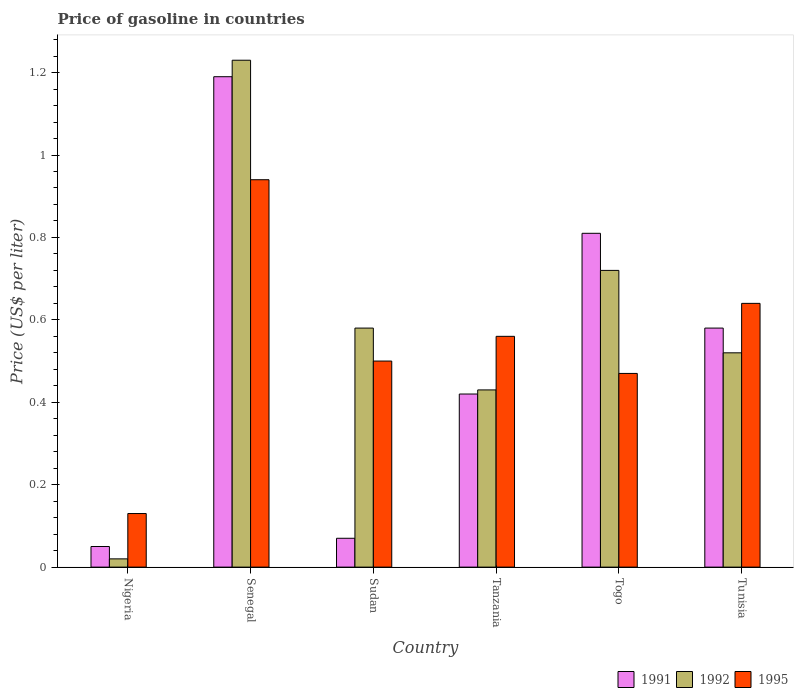How many different coloured bars are there?
Offer a terse response. 3. Are the number of bars per tick equal to the number of legend labels?
Ensure brevity in your answer.  Yes. Are the number of bars on each tick of the X-axis equal?
Keep it short and to the point. Yes. How many bars are there on the 5th tick from the left?
Your response must be concise. 3. What is the label of the 2nd group of bars from the left?
Your answer should be very brief. Senegal. In how many cases, is the number of bars for a given country not equal to the number of legend labels?
Make the answer very short. 0. What is the price of gasoline in 1995 in Tunisia?
Provide a succinct answer. 0.64. In which country was the price of gasoline in 1992 maximum?
Offer a very short reply. Senegal. In which country was the price of gasoline in 1992 minimum?
Provide a succinct answer. Nigeria. What is the total price of gasoline in 1992 in the graph?
Give a very brief answer. 3.5. What is the difference between the price of gasoline in 1992 in Nigeria and that in Tanzania?
Ensure brevity in your answer.  -0.41. What is the difference between the price of gasoline in 1992 in Togo and the price of gasoline in 1991 in Sudan?
Offer a very short reply. 0.65. What is the average price of gasoline in 1992 per country?
Ensure brevity in your answer.  0.58. What is the difference between the price of gasoline of/in 1991 and price of gasoline of/in 1992 in Tanzania?
Your answer should be compact. -0.01. What is the ratio of the price of gasoline in 1995 in Tanzania to that in Tunisia?
Offer a terse response. 0.88. What is the difference between the highest and the second highest price of gasoline in 1995?
Your answer should be very brief. 0.3. What is the difference between the highest and the lowest price of gasoline in 1995?
Make the answer very short. 0.81. In how many countries, is the price of gasoline in 1995 greater than the average price of gasoline in 1995 taken over all countries?
Make the answer very short. 3. Is it the case that in every country, the sum of the price of gasoline in 1992 and price of gasoline in 1991 is greater than the price of gasoline in 1995?
Make the answer very short. No. How many bars are there?
Offer a very short reply. 18. Are all the bars in the graph horizontal?
Your response must be concise. No. What is the difference between two consecutive major ticks on the Y-axis?
Offer a very short reply. 0.2. Where does the legend appear in the graph?
Offer a terse response. Bottom right. What is the title of the graph?
Your response must be concise. Price of gasoline in countries. What is the label or title of the Y-axis?
Give a very brief answer. Price (US$ per liter). What is the Price (US$ per liter) of 1992 in Nigeria?
Make the answer very short. 0.02. What is the Price (US$ per liter) in 1995 in Nigeria?
Make the answer very short. 0.13. What is the Price (US$ per liter) in 1991 in Senegal?
Provide a short and direct response. 1.19. What is the Price (US$ per liter) in 1992 in Senegal?
Provide a short and direct response. 1.23. What is the Price (US$ per liter) of 1991 in Sudan?
Make the answer very short. 0.07. What is the Price (US$ per liter) in 1992 in Sudan?
Make the answer very short. 0.58. What is the Price (US$ per liter) of 1995 in Sudan?
Offer a very short reply. 0.5. What is the Price (US$ per liter) of 1991 in Tanzania?
Your answer should be very brief. 0.42. What is the Price (US$ per liter) of 1992 in Tanzania?
Provide a succinct answer. 0.43. What is the Price (US$ per liter) of 1995 in Tanzania?
Your response must be concise. 0.56. What is the Price (US$ per liter) of 1991 in Togo?
Offer a very short reply. 0.81. What is the Price (US$ per liter) in 1992 in Togo?
Ensure brevity in your answer.  0.72. What is the Price (US$ per liter) of 1995 in Togo?
Give a very brief answer. 0.47. What is the Price (US$ per liter) in 1991 in Tunisia?
Keep it short and to the point. 0.58. What is the Price (US$ per liter) in 1992 in Tunisia?
Offer a terse response. 0.52. What is the Price (US$ per liter) in 1995 in Tunisia?
Offer a very short reply. 0.64. Across all countries, what is the maximum Price (US$ per liter) in 1991?
Your answer should be very brief. 1.19. Across all countries, what is the maximum Price (US$ per liter) in 1992?
Offer a very short reply. 1.23. Across all countries, what is the maximum Price (US$ per liter) of 1995?
Your response must be concise. 0.94. Across all countries, what is the minimum Price (US$ per liter) in 1992?
Offer a terse response. 0.02. Across all countries, what is the minimum Price (US$ per liter) of 1995?
Your answer should be compact. 0.13. What is the total Price (US$ per liter) in 1991 in the graph?
Provide a short and direct response. 3.12. What is the total Price (US$ per liter) in 1995 in the graph?
Make the answer very short. 3.24. What is the difference between the Price (US$ per liter) of 1991 in Nigeria and that in Senegal?
Your response must be concise. -1.14. What is the difference between the Price (US$ per liter) of 1992 in Nigeria and that in Senegal?
Your answer should be very brief. -1.21. What is the difference between the Price (US$ per liter) in 1995 in Nigeria and that in Senegal?
Make the answer very short. -0.81. What is the difference between the Price (US$ per liter) of 1991 in Nigeria and that in Sudan?
Offer a very short reply. -0.02. What is the difference between the Price (US$ per liter) of 1992 in Nigeria and that in Sudan?
Your answer should be very brief. -0.56. What is the difference between the Price (US$ per liter) in 1995 in Nigeria and that in Sudan?
Ensure brevity in your answer.  -0.37. What is the difference between the Price (US$ per liter) in 1991 in Nigeria and that in Tanzania?
Your answer should be very brief. -0.37. What is the difference between the Price (US$ per liter) in 1992 in Nigeria and that in Tanzania?
Offer a terse response. -0.41. What is the difference between the Price (US$ per liter) in 1995 in Nigeria and that in Tanzania?
Keep it short and to the point. -0.43. What is the difference between the Price (US$ per liter) of 1991 in Nigeria and that in Togo?
Offer a terse response. -0.76. What is the difference between the Price (US$ per liter) in 1995 in Nigeria and that in Togo?
Give a very brief answer. -0.34. What is the difference between the Price (US$ per liter) in 1991 in Nigeria and that in Tunisia?
Give a very brief answer. -0.53. What is the difference between the Price (US$ per liter) in 1992 in Nigeria and that in Tunisia?
Keep it short and to the point. -0.5. What is the difference between the Price (US$ per liter) of 1995 in Nigeria and that in Tunisia?
Your response must be concise. -0.51. What is the difference between the Price (US$ per liter) in 1991 in Senegal and that in Sudan?
Ensure brevity in your answer.  1.12. What is the difference between the Price (US$ per liter) in 1992 in Senegal and that in Sudan?
Give a very brief answer. 0.65. What is the difference between the Price (US$ per liter) in 1995 in Senegal and that in Sudan?
Give a very brief answer. 0.44. What is the difference between the Price (US$ per liter) of 1991 in Senegal and that in Tanzania?
Provide a short and direct response. 0.77. What is the difference between the Price (US$ per liter) in 1995 in Senegal and that in Tanzania?
Your answer should be very brief. 0.38. What is the difference between the Price (US$ per liter) in 1991 in Senegal and that in Togo?
Your answer should be compact. 0.38. What is the difference between the Price (US$ per liter) in 1992 in Senegal and that in Togo?
Make the answer very short. 0.51. What is the difference between the Price (US$ per liter) in 1995 in Senegal and that in Togo?
Offer a terse response. 0.47. What is the difference between the Price (US$ per liter) of 1991 in Senegal and that in Tunisia?
Offer a terse response. 0.61. What is the difference between the Price (US$ per liter) of 1992 in Senegal and that in Tunisia?
Offer a very short reply. 0.71. What is the difference between the Price (US$ per liter) in 1991 in Sudan and that in Tanzania?
Your answer should be very brief. -0.35. What is the difference between the Price (US$ per liter) of 1992 in Sudan and that in Tanzania?
Offer a terse response. 0.15. What is the difference between the Price (US$ per liter) in 1995 in Sudan and that in Tanzania?
Your response must be concise. -0.06. What is the difference between the Price (US$ per liter) of 1991 in Sudan and that in Togo?
Ensure brevity in your answer.  -0.74. What is the difference between the Price (US$ per liter) in 1992 in Sudan and that in Togo?
Make the answer very short. -0.14. What is the difference between the Price (US$ per liter) of 1991 in Sudan and that in Tunisia?
Provide a short and direct response. -0.51. What is the difference between the Price (US$ per liter) of 1992 in Sudan and that in Tunisia?
Provide a succinct answer. 0.06. What is the difference between the Price (US$ per liter) in 1995 in Sudan and that in Tunisia?
Offer a very short reply. -0.14. What is the difference between the Price (US$ per liter) in 1991 in Tanzania and that in Togo?
Your answer should be very brief. -0.39. What is the difference between the Price (US$ per liter) of 1992 in Tanzania and that in Togo?
Give a very brief answer. -0.29. What is the difference between the Price (US$ per liter) of 1995 in Tanzania and that in Togo?
Your response must be concise. 0.09. What is the difference between the Price (US$ per liter) of 1991 in Tanzania and that in Tunisia?
Provide a short and direct response. -0.16. What is the difference between the Price (US$ per liter) in 1992 in Tanzania and that in Tunisia?
Your response must be concise. -0.09. What is the difference between the Price (US$ per liter) of 1995 in Tanzania and that in Tunisia?
Keep it short and to the point. -0.08. What is the difference between the Price (US$ per liter) of 1991 in Togo and that in Tunisia?
Make the answer very short. 0.23. What is the difference between the Price (US$ per liter) of 1992 in Togo and that in Tunisia?
Keep it short and to the point. 0.2. What is the difference between the Price (US$ per liter) in 1995 in Togo and that in Tunisia?
Provide a succinct answer. -0.17. What is the difference between the Price (US$ per liter) in 1991 in Nigeria and the Price (US$ per liter) in 1992 in Senegal?
Ensure brevity in your answer.  -1.18. What is the difference between the Price (US$ per liter) of 1991 in Nigeria and the Price (US$ per liter) of 1995 in Senegal?
Your answer should be compact. -0.89. What is the difference between the Price (US$ per liter) in 1992 in Nigeria and the Price (US$ per liter) in 1995 in Senegal?
Make the answer very short. -0.92. What is the difference between the Price (US$ per liter) in 1991 in Nigeria and the Price (US$ per liter) in 1992 in Sudan?
Offer a very short reply. -0.53. What is the difference between the Price (US$ per liter) of 1991 in Nigeria and the Price (US$ per liter) of 1995 in Sudan?
Provide a succinct answer. -0.45. What is the difference between the Price (US$ per liter) in 1992 in Nigeria and the Price (US$ per liter) in 1995 in Sudan?
Your answer should be compact. -0.48. What is the difference between the Price (US$ per liter) in 1991 in Nigeria and the Price (US$ per liter) in 1992 in Tanzania?
Your answer should be very brief. -0.38. What is the difference between the Price (US$ per liter) of 1991 in Nigeria and the Price (US$ per liter) of 1995 in Tanzania?
Your answer should be compact. -0.51. What is the difference between the Price (US$ per liter) of 1992 in Nigeria and the Price (US$ per liter) of 1995 in Tanzania?
Offer a terse response. -0.54. What is the difference between the Price (US$ per liter) in 1991 in Nigeria and the Price (US$ per liter) in 1992 in Togo?
Offer a very short reply. -0.67. What is the difference between the Price (US$ per liter) in 1991 in Nigeria and the Price (US$ per liter) in 1995 in Togo?
Your response must be concise. -0.42. What is the difference between the Price (US$ per liter) of 1992 in Nigeria and the Price (US$ per liter) of 1995 in Togo?
Keep it short and to the point. -0.45. What is the difference between the Price (US$ per liter) in 1991 in Nigeria and the Price (US$ per liter) in 1992 in Tunisia?
Provide a succinct answer. -0.47. What is the difference between the Price (US$ per liter) of 1991 in Nigeria and the Price (US$ per liter) of 1995 in Tunisia?
Offer a very short reply. -0.59. What is the difference between the Price (US$ per liter) of 1992 in Nigeria and the Price (US$ per liter) of 1995 in Tunisia?
Make the answer very short. -0.62. What is the difference between the Price (US$ per liter) in 1991 in Senegal and the Price (US$ per liter) in 1992 in Sudan?
Ensure brevity in your answer.  0.61. What is the difference between the Price (US$ per liter) in 1991 in Senegal and the Price (US$ per liter) in 1995 in Sudan?
Ensure brevity in your answer.  0.69. What is the difference between the Price (US$ per liter) in 1992 in Senegal and the Price (US$ per liter) in 1995 in Sudan?
Make the answer very short. 0.73. What is the difference between the Price (US$ per liter) of 1991 in Senegal and the Price (US$ per liter) of 1992 in Tanzania?
Give a very brief answer. 0.76. What is the difference between the Price (US$ per liter) of 1991 in Senegal and the Price (US$ per liter) of 1995 in Tanzania?
Provide a succinct answer. 0.63. What is the difference between the Price (US$ per liter) of 1992 in Senegal and the Price (US$ per liter) of 1995 in Tanzania?
Keep it short and to the point. 0.67. What is the difference between the Price (US$ per liter) of 1991 in Senegal and the Price (US$ per liter) of 1992 in Togo?
Make the answer very short. 0.47. What is the difference between the Price (US$ per liter) in 1991 in Senegal and the Price (US$ per liter) in 1995 in Togo?
Ensure brevity in your answer.  0.72. What is the difference between the Price (US$ per liter) of 1992 in Senegal and the Price (US$ per liter) of 1995 in Togo?
Your answer should be very brief. 0.76. What is the difference between the Price (US$ per liter) in 1991 in Senegal and the Price (US$ per liter) in 1992 in Tunisia?
Ensure brevity in your answer.  0.67. What is the difference between the Price (US$ per liter) in 1991 in Senegal and the Price (US$ per liter) in 1995 in Tunisia?
Ensure brevity in your answer.  0.55. What is the difference between the Price (US$ per liter) of 1992 in Senegal and the Price (US$ per liter) of 1995 in Tunisia?
Your response must be concise. 0.59. What is the difference between the Price (US$ per liter) in 1991 in Sudan and the Price (US$ per liter) in 1992 in Tanzania?
Make the answer very short. -0.36. What is the difference between the Price (US$ per liter) in 1991 in Sudan and the Price (US$ per liter) in 1995 in Tanzania?
Provide a succinct answer. -0.49. What is the difference between the Price (US$ per liter) of 1991 in Sudan and the Price (US$ per liter) of 1992 in Togo?
Give a very brief answer. -0.65. What is the difference between the Price (US$ per liter) of 1992 in Sudan and the Price (US$ per liter) of 1995 in Togo?
Offer a terse response. 0.11. What is the difference between the Price (US$ per liter) in 1991 in Sudan and the Price (US$ per liter) in 1992 in Tunisia?
Your response must be concise. -0.45. What is the difference between the Price (US$ per liter) of 1991 in Sudan and the Price (US$ per liter) of 1995 in Tunisia?
Make the answer very short. -0.57. What is the difference between the Price (US$ per liter) in 1992 in Sudan and the Price (US$ per liter) in 1995 in Tunisia?
Provide a succinct answer. -0.06. What is the difference between the Price (US$ per liter) of 1991 in Tanzania and the Price (US$ per liter) of 1995 in Togo?
Your response must be concise. -0.05. What is the difference between the Price (US$ per liter) of 1992 in Tanzania and the Price (US$ per liter) of 1995 in Togo?
Offer a very short reply. -0.04. What is the difference between the Price (US$ per liter) in 1991 in Tanzania and the Price (US$ per liter) in 1995 in Tunisia?
Provide a succinct answer. -0.22. What is the difference between the Price (US$ per liter) of 1992 in Tanzania and the Price (US$ per liter) of 1995 in Tunisia?
Provide a short and direct response. -0.21. What is the difference between the Price (US$ per liter) in 1991 in Togo and the Price (US$ per liter) in 1992 in Tunisia?
Your answer should be very brief. 0.29. What is the difference between the Price (US$ per liter) in 1991 in Togo and the Price (US$ per liter) in 1995 in Tunisia?
Your answer should be very brief. 0.17. What is the difference between the Price (US$ per liter) of 1992 in Togo and the Price (US$ per liter) of 1995 in Tunisia?
Offer a terse response. 0.08. What is the average Price (US$ per liter) in 1991 per country?
Keep it short and to the point. 0.52. What is the average Price (US$ per liter) of 1992 per country?
Provide a succinct answer. 0.58. What is the average Price (US$ per liter) of 1995 per country?
Make the answer very short. 0.54. What is the difference between the Price (US$ per liter) in 1991 and Price (US$ per liter) in 1995 in Nigeria?
Provide a short and direct response. -0.08. What is the difference between the Price (US$ per liter) in 1992 and Price (US$ per liter) in 1995 in Nigeria?
Provide a short and direct response. -0.11. What is the difference between the Price (US$ per liter) of 1991 and Price (US$ per liter) of 1992 in Senegal?
Ensure brevity in your answer.  -0.04. What is the difference between the Price (US$ per liter) of 1992 and Price (US$ per liter) of 1995 in Senegal?
Your answer should be very brief. 0.29. What is the difference between the Price (US$ per liter) in 1991 and Price (US$ per liter) in 1992 in Sudan?
Provide a succinct answer. -0.51. What is the difference between the Price (US$ per liter) of 1991 and Price (US$ per liter) of 1995 in Sudan?
Ensure brevity in your answer.  -0.43. What is the difference between the Price (US$ per liter) of 1992 and Price (US$ per liter) of 1995 in Sudan?
Make the answer very short. 0.08. What is the difference between the Price (US$ per liter) in 1991 and Price (US$ per liter) in 1992 in Tanzania?
Your response must be concise. -0.01. What is the difference between the Price (US$ per liter) in 1991 and Price (US$ per liter) in 1995 in Tanzania?
Provide a succinct answer. -0.14. What is the difference between the Price (US$ per liter) in 1992 and Price (US$ per liter) in 1995 in Tanzania?
Ensure brevity in your answer.  -0.13. What is the difference between the Price (US$ per liter) of 1991 and Price (US$ per liter) of 1992 in Togo?
Your response must be concise. 0.09. What is the difference between the Price (US$ per liter) in 1991 and Price (US$ per liter) in 1995 in Togo?
Provide a short and direct response. 0.34. What is the difference between the Price (US$ per liter) in 1991 and Price (US$ per liter) in 1995 in Tunisia?
Your response must be concise. -0.06. What is the difference between the Price (US$ per liter) in 1992 and Price (US$ per liter) in 1995 in Tunisia?
Provide a short and direct response. -0.12. What is the ratio of the Price (US$ per liter) in 1991 in Nigeria to that in Senegal?
Provide a short and direct response. 0.04. What is the ratio of the Price (US$ per liter) in 1992 in Nigeria to that in Senegal?
Give a very brief answer. 0.02. What is the ratio of the Price (US$ per liter) in 1995 in Nigeria to that in Senegal?
Offer a very short reply. 0.14. What is the ratio of the Price (US$ per liter) of 1991 in Nigeria to that in Sudan?
Provide a succinct answer. 0.71. What is the ratio of the Price (US$ per liter) in 1992 in Nigeria to that in Sudan?
Ensure brevity in your answer.  0.03. What is the ratio of the Price (US$ per liter) in 1995 in Nigeria to that in Sudan?
Your response must be concise. 0.26. What is the ratio of the Price (US$ per liter) of 1991 in Nigeria to that in Tanzania?
Ensure brevity in your answer.  0.12. What is the ratio of the Price (US$ per liter) in 1992 in Nigeria to that in Tanzania?
Offer a very short reply. 0.05. What is the ratio of the Price (US$ per liter) in 1995 in Nigeria to that in Tanzania?
Offer a very short reply. 0.23. What is the ratio of the Price (US$ per liter) in 1991 in Nigeria to that in Togo?
Offer a very short reply. 0.06. What is the ratio of the Price (US$ per liter) of 1992 in Nigeria to that in Togo?
Ensure brevity in your answer.  0.03. What is the ratio of the Price (US$ per liter) of 1995 in Nigeria to that in Togo?
Provide a succinct answer. 0.28. What is the ratio of the Price (US$ per liter) in 1991 in Nigeria to that in Tunisia?
Ensure brevity in your answer.  0.09. What is the ratio of the Price (US$ per liter) in 1992 in Nigeria to that in Tunisia?
Provide a succinct answer. 0.04. What is the ratio of the Price (US$ per liter) of 1995 in Nigeria to that in Tunisia?
Provide a short and direct response. 0.2. What is the ratio of the Price (US$ per liter) in 1992 in Senegal to that in Sudan?
Offer a very short reply. 2.12. What is the ratio of the Price (US$ per liter) in 1995 in Senegal to that in Sudan?
Provide a succinct answer. 1.88. What is the ratio of the Price (US$ per liter) in 1991 in Senegal to that in Tanzania?
Make the answer very short. 2.83. What is the ratio of the Price (US$ per liter) of 1992 in Senegal to that in Tanzania?
Provide a succinct answer. 2.86. What is the ratio of the Price (US$ per liter) in 1995 in Senegal to that in Tanzania?
Provide a short and direct response. 1.68. What is the ratio of the Price (US$ per liter) in 1991 in Senegal to that in Togo?
Make the answer very short. 1.47. What is the ratio of the Price (US$ per liter) in 1992 in Senegal to that in Togo?
Your answer should be compact. 1.71. What is the ratio of the Price (US$ per liter) of 1991 in Senegal to that in Tunisia?
Provide a short and direct response. 2.05. What is the ratio of the Price (US$ per liter) in 1992 in Senegal to that in Tunisia?
Your answer should be very brief. 2.37. What is the ratio of the Price (US$ per liter) of 1995 in Senegal to that in Tunisia?
Make the answer very short. 1.47. What is the ratio of the Price (US$ per liter) of 1992 in Sudan to that in Tanzania?
Make the answer very short. 1.35. What is the ratio of the Price (US$ per liter) of 1995 in Sudan to that in Tanzania?
Keep it short and to the point. 0.89. What is the ratio of the Price (US$ per liter) in 1991 in Sudan to that in Togo?
Provide a short and direct response. 0.09. What is the ratio of the Price (US$ per liter) of 1992 in Sudan to that in Togo?
Offer a very short reply. 0.81. What is the ratio of the Price (US$ per liter) in 1995 in Sudan to that in Togo?
Ensure brevity in your answer.  1.06. What is the ratio of the Price (US$ per liter) of 1991 in Sudan to that in Tunisia?
Ensure brevity in your answer.  0.12. What is the ratio of the Price (US$ per liter) in 1992 in Sudan to that in Tunisia?
Make the answer very short. 1.12. What is the ratio of the Price (US$ per liter) in 1995 in Sudan to that in Tunisia?
Keep it short and to the point. 0.78. What is the ratio of the Price (US$ per liter) in 1991 in Tanzania to that in Togo?
Your response must be concise. 0.52. What is the ratio of the Price (US$ per liter) in 1992 in Tanzania to that in Togo?
Your answer should be very brief. 0.6. What is the ratio of the Price (US$ per liter) in 1995 in Tanzania to that in Togo?
Provide a short and direct response. 1.19. What is the ratio of the Price (US$ per liter) in 1991 in Tanzania to that in Tunisia?
Keep it short and to the point. 0.72. What is the ratio of the Price (US$ per liter) of 1992 in Tanzania to that in Tunisia?
Your answer should be very brief. 0.83. What is the ratio of the Price (US$ per liter) of 1995 in Tanzania to that in Tunisia?
Provide a short and direct response. 0.88. What is the ratio of the Price (US$ per liter) in 1991 in Togo to that in Tunisia?
Your answer should be very brief. 1.4. What is the ratio of the Price (US$ per liter) in 1992 in Togo to that in Tunisia?
Offer a very short reply. 1.38. What is the ratio of the Price (US$ per liter) in 1995 in Togo to that in Tunisia?
Give a very brief answer. 0.73. What is the difference between the highest and the second highest Price (US$ per liter) in 1991?
Provide a succinct answer. 0.38. What is the difference between the highest and the second highest Price (US$ per liter) in 1992?
Your response must be concise. 0.51. What is the difference between the highest and the lowest Price (US$ per liter) of 1991?
Offer a very short reply. 1.14. What is the difference between the highest and the lowest Price (US$ per liter) in 1992?
Provide a short and direct response. 1.21. What is the difference between the highest and the lowest Price (US$ per liter) of 1995?
Your response must be concise. 0.81. 